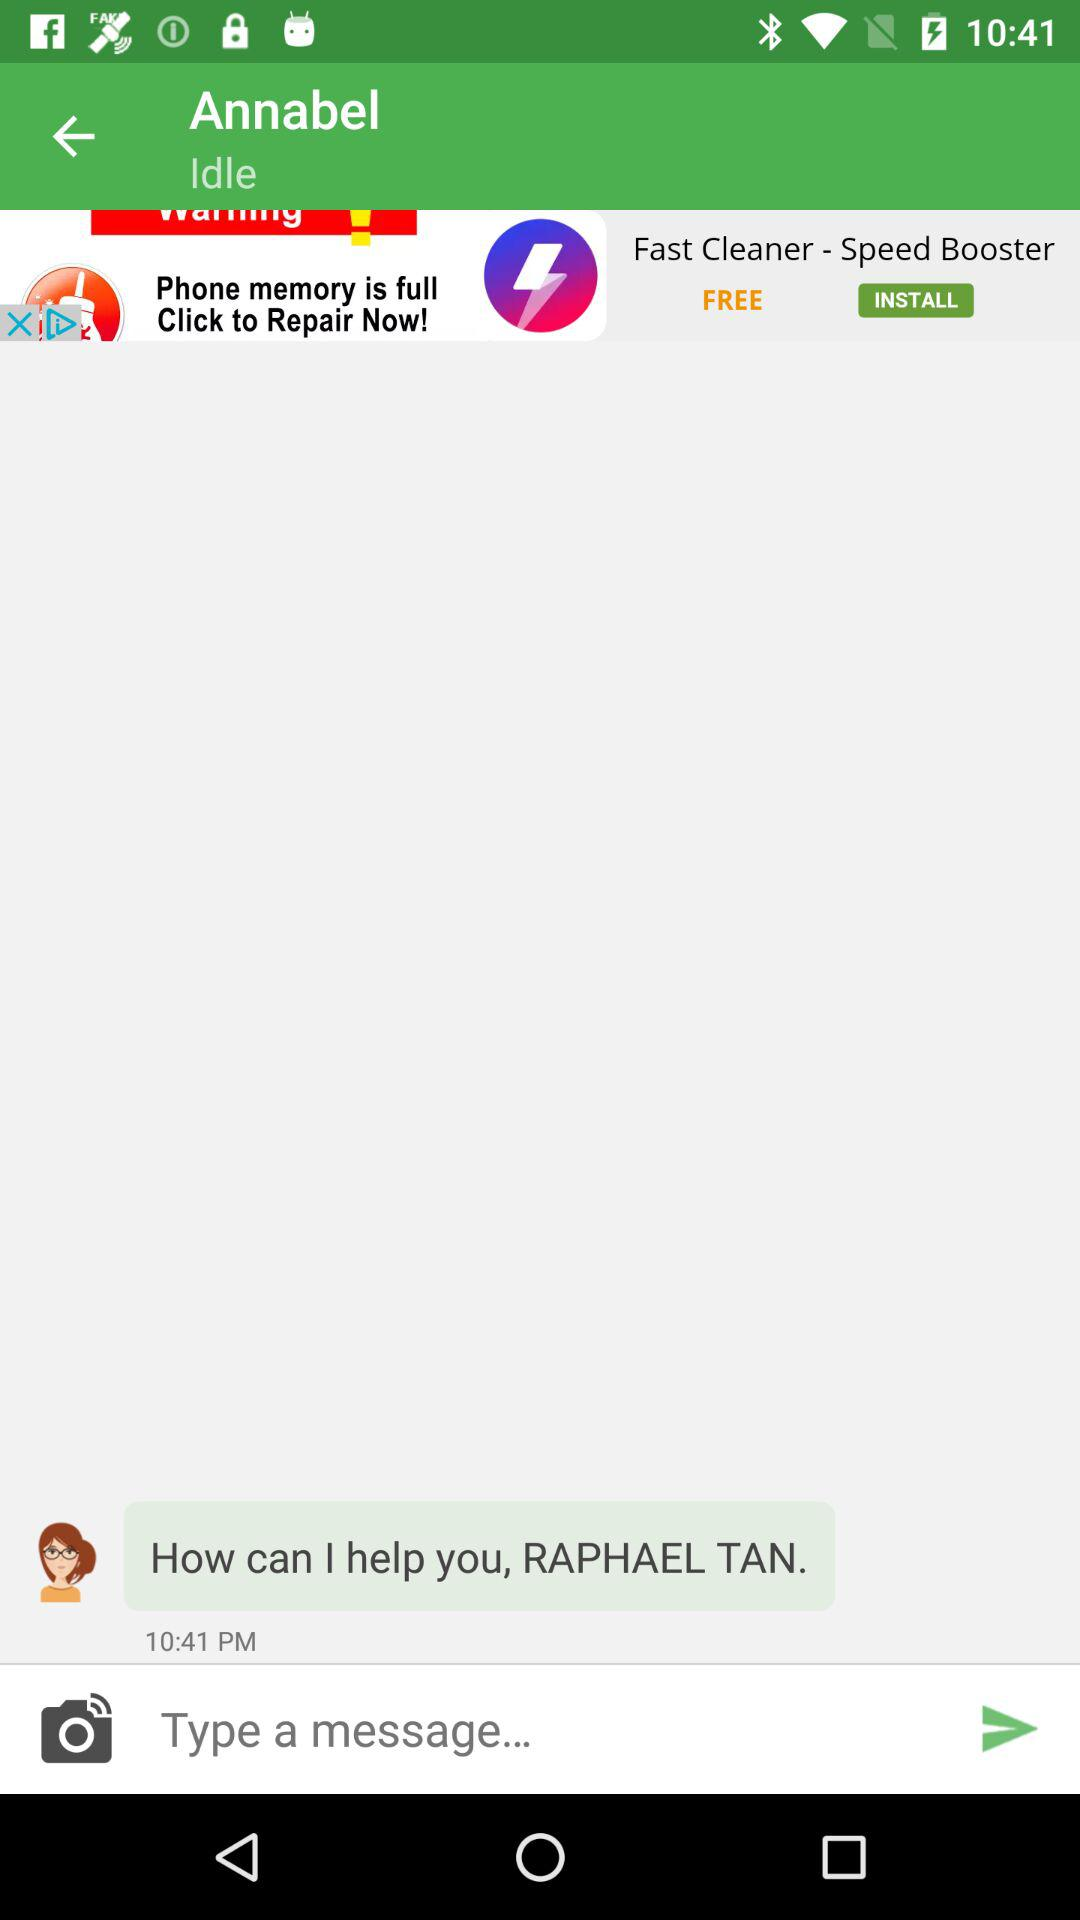At what time did Annabel send a message to Raphael Tan? Annabel sent a message to Raphael Tan at 10:41 PM. 